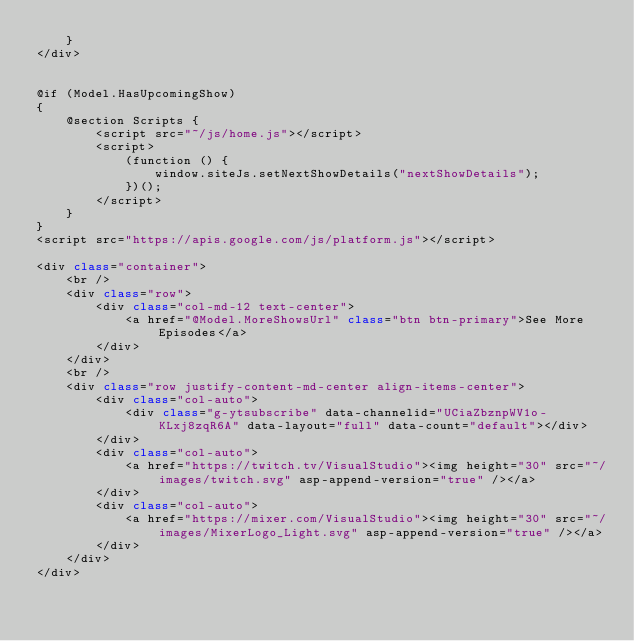Convert code to text. <code><loc_0><loc_0><loc_500><loc_500><_C#_>    }
</div>


@if (Model.HasUpcomingShow)
{
    @section Scripts {
        <script src="~/js/home.js"></script>
        <script>
            (function () {
                window.siteJs.setNextShowDetails("nextShowDetails");
            })();
        </script>
    }
}
<script src="https://apis.google.com/js/platform.js"></script>

<div class="container">
    <br />
    <div class="row">
        <div class="col-md-12 text-center">
            <a href="@Model.MoreShowsUrl" class="btn btn-primary">See More Episodes</a>
        </div>
    </div>
    <br />
    <div class="row justify-content-md-center align-items-center">
        <div class="col-auto">
            <div class="g-ytsubscribe" data-channelid="UCiaZbznpWV1o-KLxj8zqR6A" data-layout="full" data-count="default"></div>
        </div>
        <div class="col-auto">
            <a href="https://twitch.tv/VisualStudio"><img height="30" src="~/images/twitch.svg" asp-append-version="true" /></a>
        </div>
        <div class="col-auto">
            <a href="https://mixer.com/VisualStudio"><img height="30" src="~/images/MixerLogo_Light.svg" asp-append-version="true" /></a>
        </div>
    </div>
</div>
</code> 